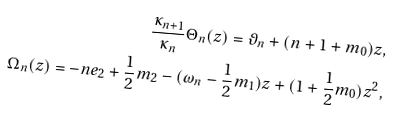<formula> <loc_0><loc_0><loc_500><loc_500>\frac { \kappa _ { n + 1 } } { \kappa _ { n } } \Theta _ { n } ( z ) = \vartheta _ { n } + ( n + 1 + m _ { 0 } ) z , \\ \Omega _ { n } ( z ) = - n e _ { 2 } + \frac { 1 } { 2 } m _ { 2 } - ( \omega _ { n } - \frac { 1 } { 2 } m _ { 1 } ) z + ( 1 + \frac { 1 } { 2 } m _ { 0 } ) z ^ { 2 } ,</formula> 